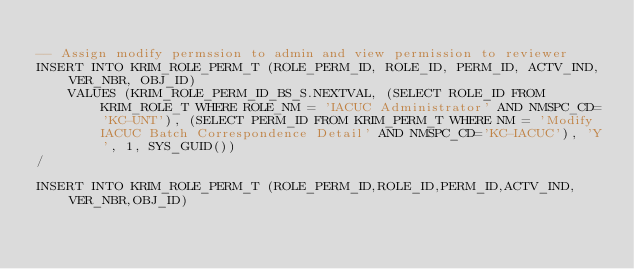<code> <loc_0><loc_0><loc_500><loc_500><_SQL_>
-- Assign modify permssion to admin and view permission to reviewer
INSERT INTO KRIM_ROLE_PERM_T (ROLE_PERM_ID, ROLE_ID, PERM_ID, ACTV_IND, VER_NBR, OBJ_ID) 
	VALUES (KRIM_ROLE_PERM_ID_BS_S.NEXTVAL, (SELECT ROLE_ID FROM KRIM_ROLE_T WHERE ROLE_NM = 'IACUC Administrator' AND NMSPC_CD='KC-UNT'), (SELECT PERM_ID FROM KRIM_PERM_T WHERE NM = 'Modify IACUC Batch Correspondence Detail' AND NMSPC_CD='KC-IACUC'), 'Y', 1, SYS_GUID())
/

INSERT INTO KRIM_ROLE_PERM_T (ROLE_PERM_ID,ROLE_ID,PERM_ID,ACTV_IND,VER_NBR,OBJ_ID) </code> 